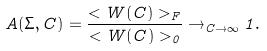Convert formula to latex. <formula><loc_0><loc_0><loc_500><loc_500>A ( \Sigma , C ) = \frac { < W ( C ) > _ { F } } { < W ( C ) > _ { 0 } } \rightarrow _ { C \to \infty } 1 .</formula> 